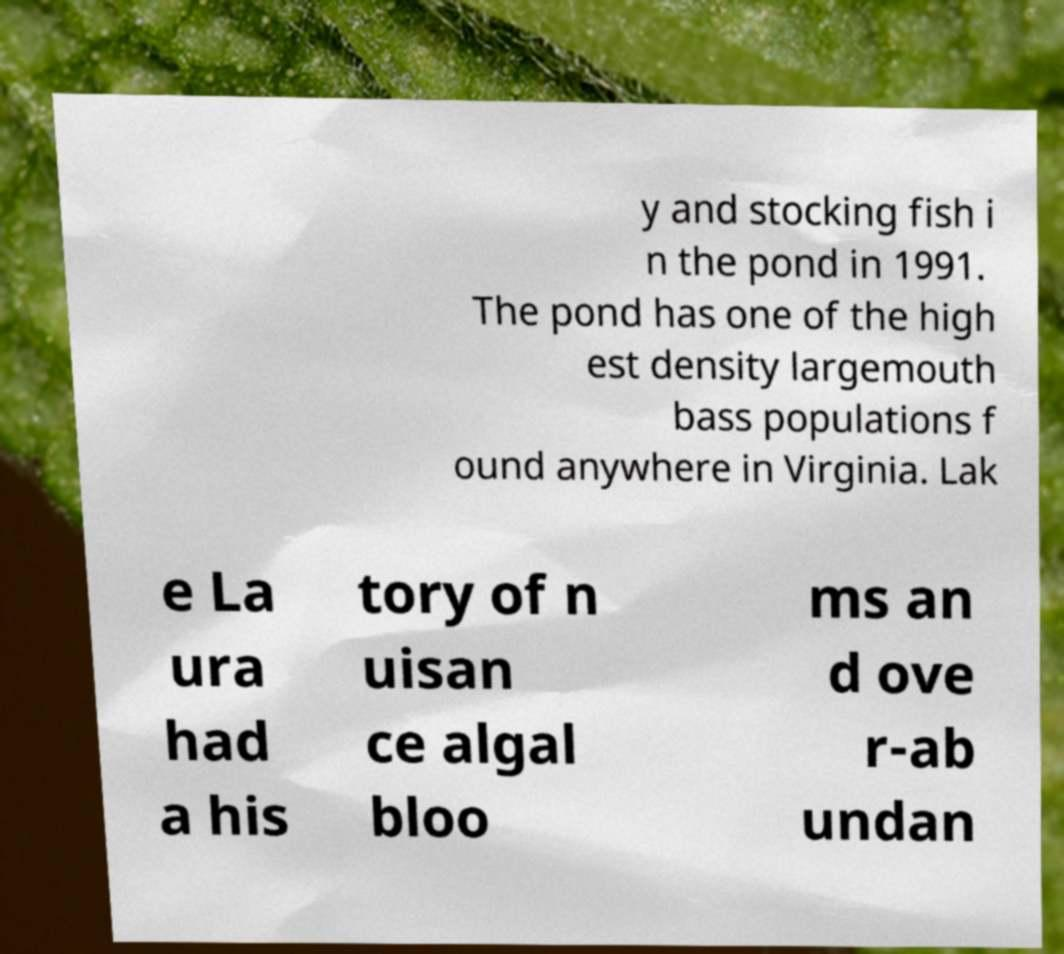Can you accurately transcribe the text from the provided image for me? y and stocking fish i n the pond in 1991. The pond has one of the high est density largemouth bass populations f ound anywhere in Virginia. Lak e La ura had a his tory of n uisan ce algal bloo ms an d ove r-ab undan 